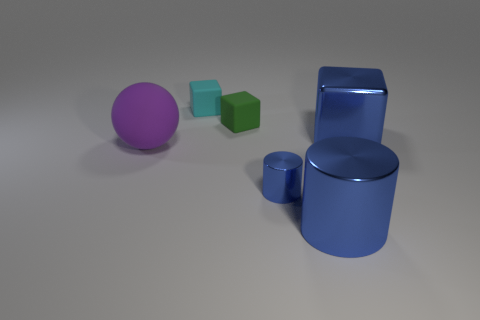Subtract all small rubber blocks. How many blocks are left? 1 Subtract 1 cubes. How many cubes are left? 2 Add 2 gray shiny blocks. How many objects exist? 8 Add 6 purple rubber cylinders. How many purple rubber cylinders exist? 6 Subtract 0 red balls. How many objects are left? 6 Subtract all cylinders. How many objects are left? 4 Subtract all gray blocks. Subtract all brown spheres. How many blocks are left? 3 Subtract all green objects. Subtract all big objects. How many objects are left? 2 Add 2 metal things. How many metal things are left? 5 